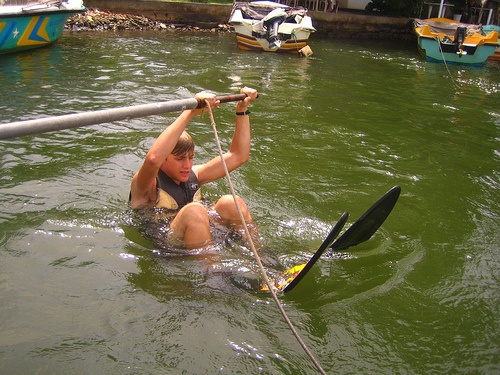Describe the objects in this image and their specific colors. I can see people in tan, brown, salmon, and maroon tones, boat in tan, ivory, black, darkgray, and gray tones, boat in tan, teal, black, white, and olive tones, boat in tan, teal, black, and orange tones, and skis in tan, black, darkgreen, and gray tones in this image. 